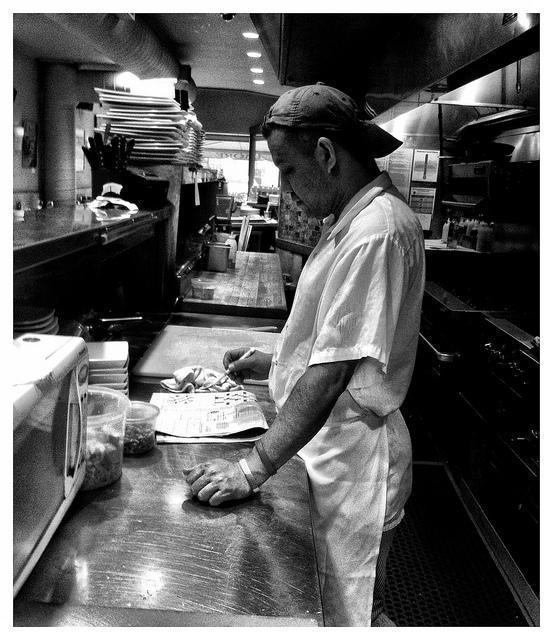What is this person's likely job title?
Select the correct answer and articulate reasoning with the following format: 'Answer: answer
Rationale: rationale.'
Options: Garbage man, electrician, waiter, line cook. Answer: line cook.
Rationale: This person is likely to be a line cook at a commercial restaurant. 